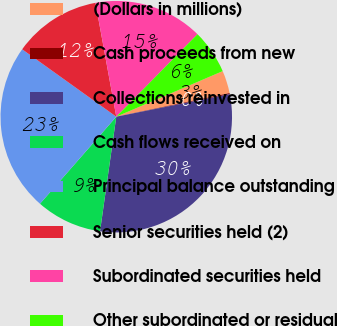Convert chart. <chart><loc_0><loc_0><loc_500><loc_500><pie_chart><fcel>(Dollars in millions)<fcel>Cash proceeds from new<fcel>Collections reinvested in<fcel>Cash flows received on<fcel>Principal balance outstanding<fcel>Senior securities held (2)<fcel>Subordinated securities held<fcel>Other subordinated or residual<nl><fcel>3.17%<fcel>0.15%<fcel>30.36%<fcel>9.21%<fcel>23.44%<fcel>12.23%<fcel>15.25%<fcel>6.19%<nl></chart> 